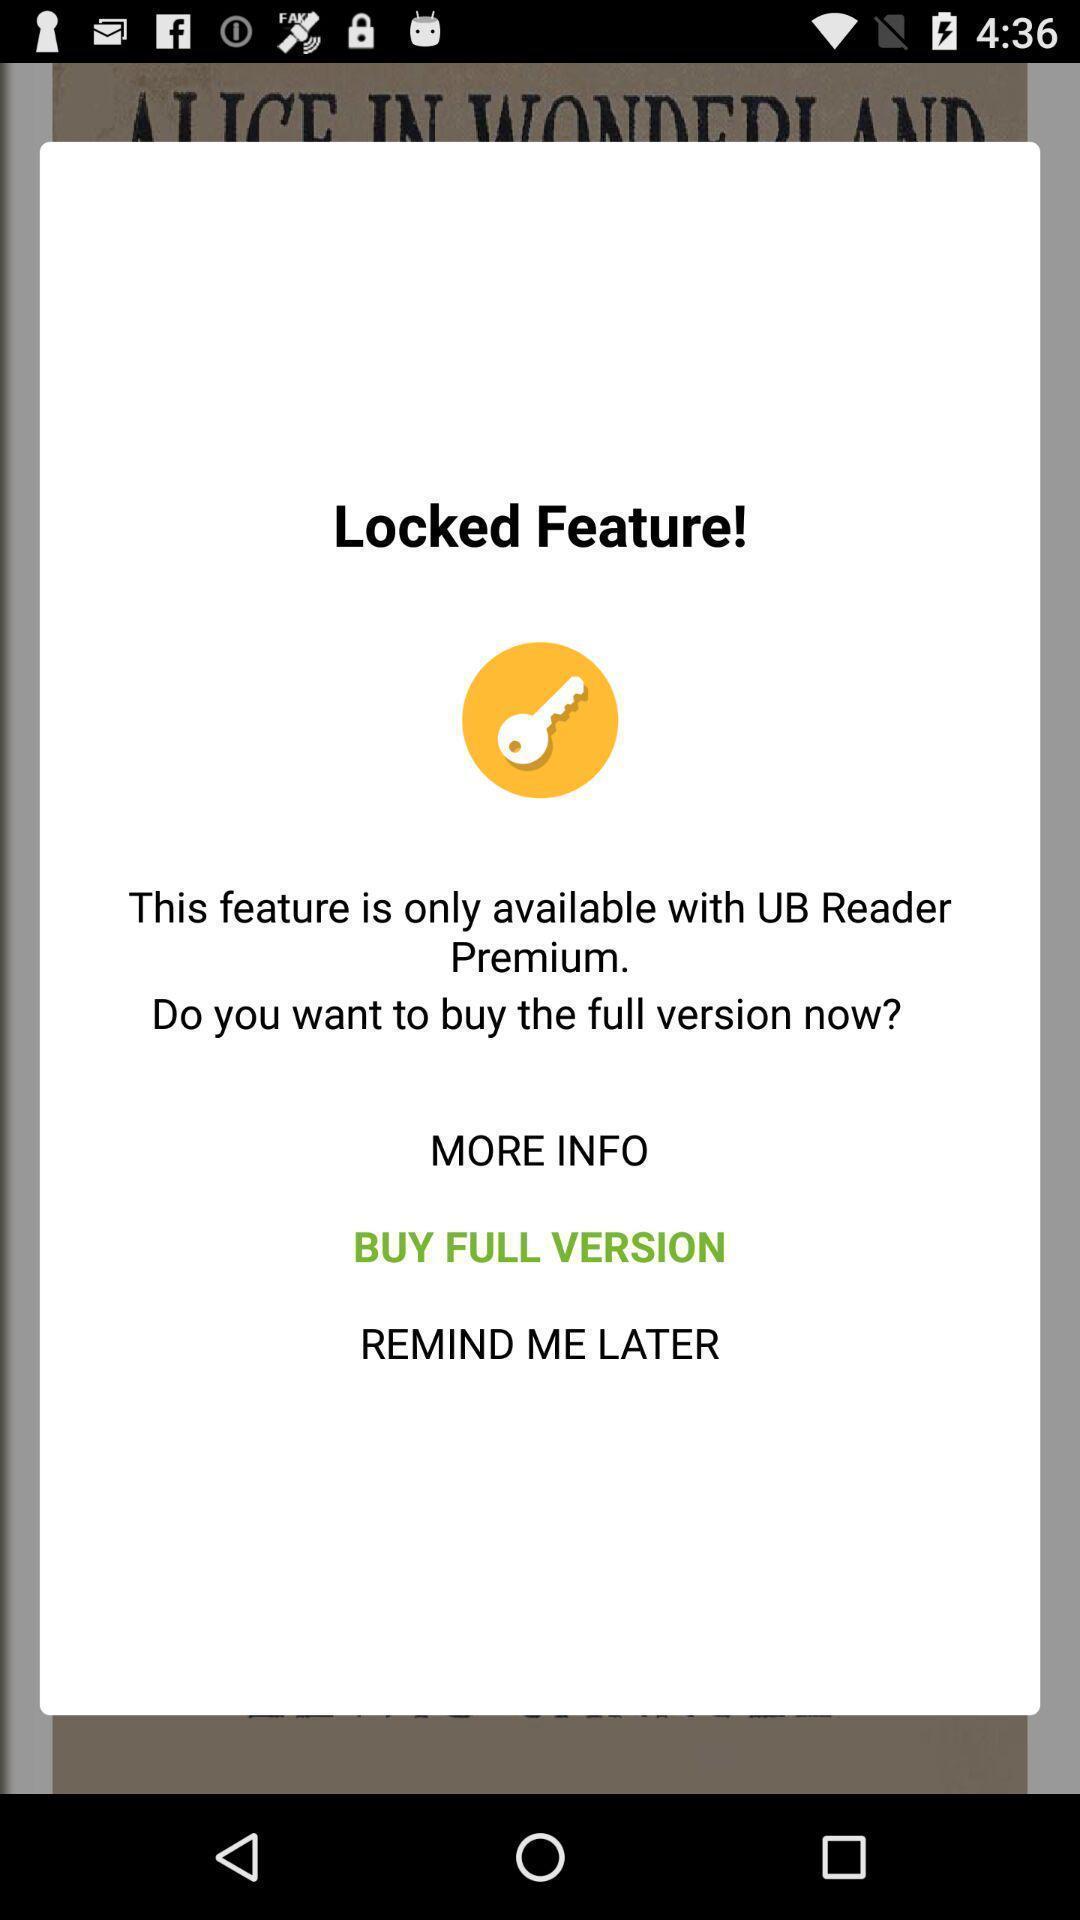What is the overall content of this screenshot? Pop-up message to get the full version to unlock feature. 